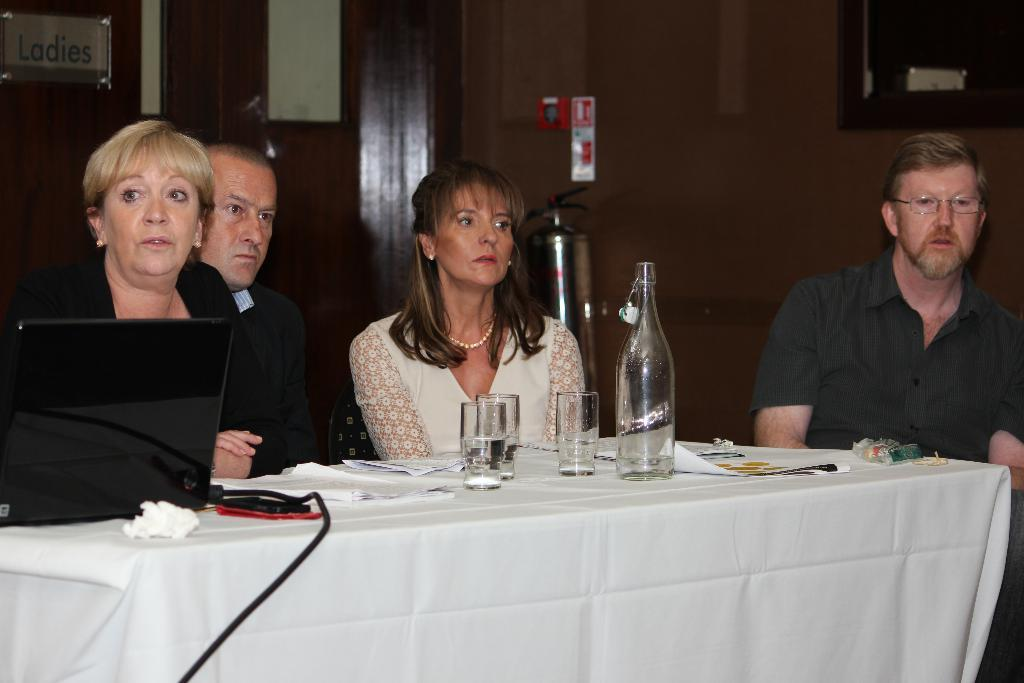How many people are in the image? There are four people in the image. What are the people doing in the image? The people are sitting on chairs and looking at someone. What is on the table in the image? There is a glass, a bottle, and a laptop on the table. What type of cow can be seen singing a song in the image? There is no cow or song present in the image. How much butter is on the table in the image? There is no butter present in the image. 